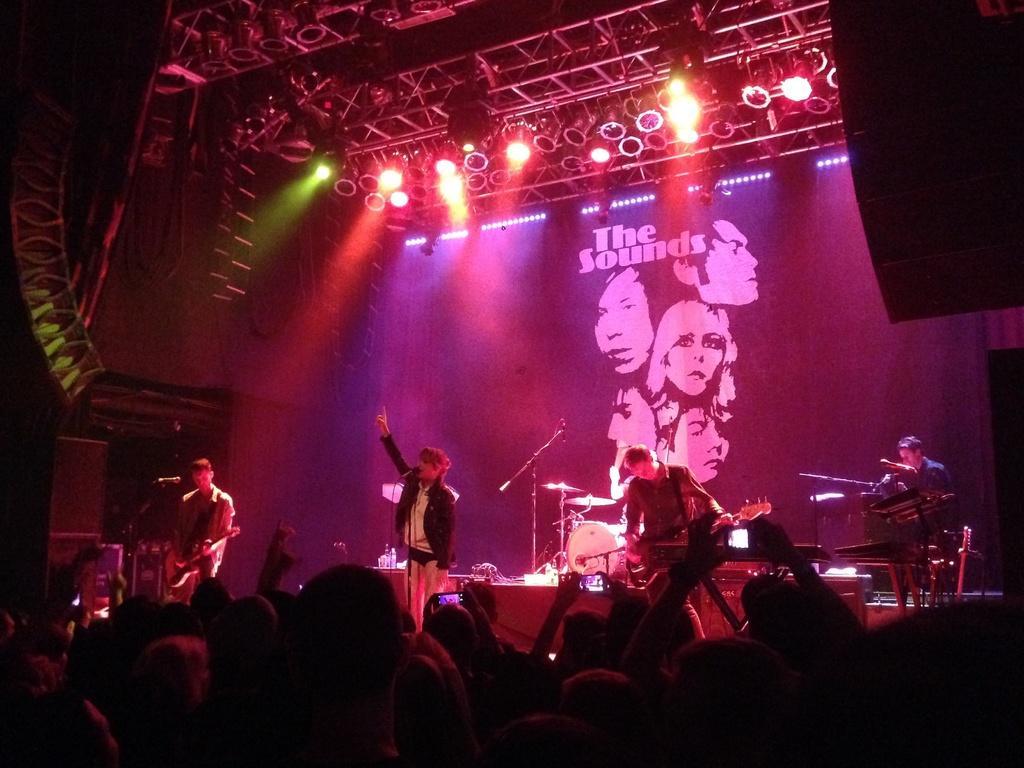Describe this image in one or two sentences. At the bottom of the image we can see a few people are standing and few people are holding mobile phone. In the center of the image we can see a few people are standing and holding some musical instruments. In front of them, we can see microphones. In the background there is a banner, lights, few musical instruments and a few other objects. 